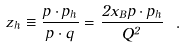<formula> <loc_0><loc_0><loc_500><loc_500>z _ { h } \equiv \frac { p \cdot p _ { h } } { p \cdot q } = \frac { 2 x _ { B } p \cdot p _ { h } } { Q ^ { 2 } } \ .</formula> 